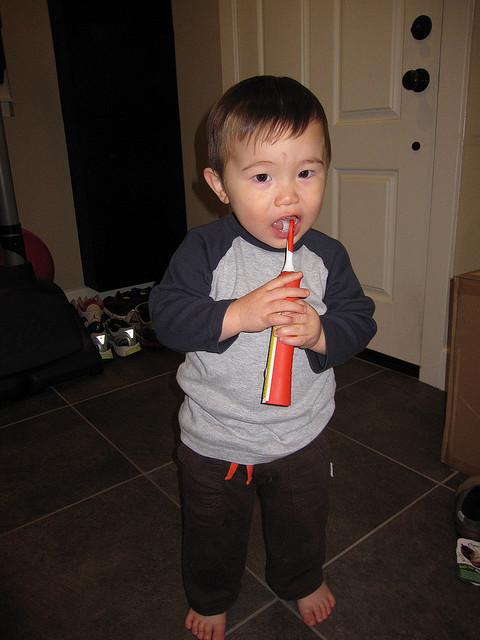Is the child standing on carpet?
Quick response, please. No. What is he doing?
Write a very short answer. Brushing teeth. What is the kid holding?
Quick response, please. Toothbrush. 